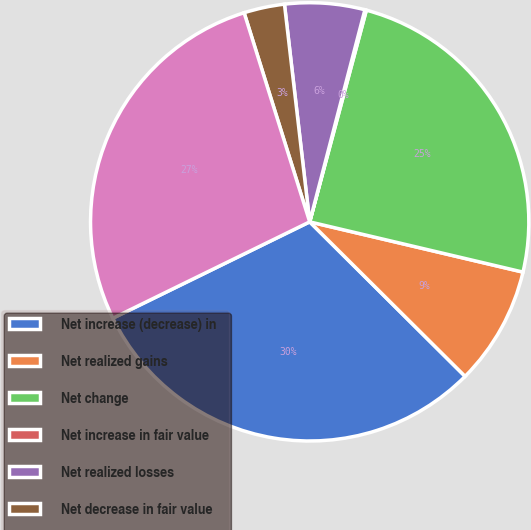<chart> <loc_0><loc_0><loc_500><loc_500><pie_chart><fcel>Net increase (decrease) in<fcel>Net realized gains<fcel>Net change<fcel>Net increase in fair value<fcel>Net realized losses<fcel>Net decrease in fair value<fcel>Total other comprehensive<nl><fcel>30.3%<fcel>8.77%<fcel>24.52%<fcel>0.11%<fcel>5.89%<fcel>3.0%<fcel>27.41%<nl></chart> 